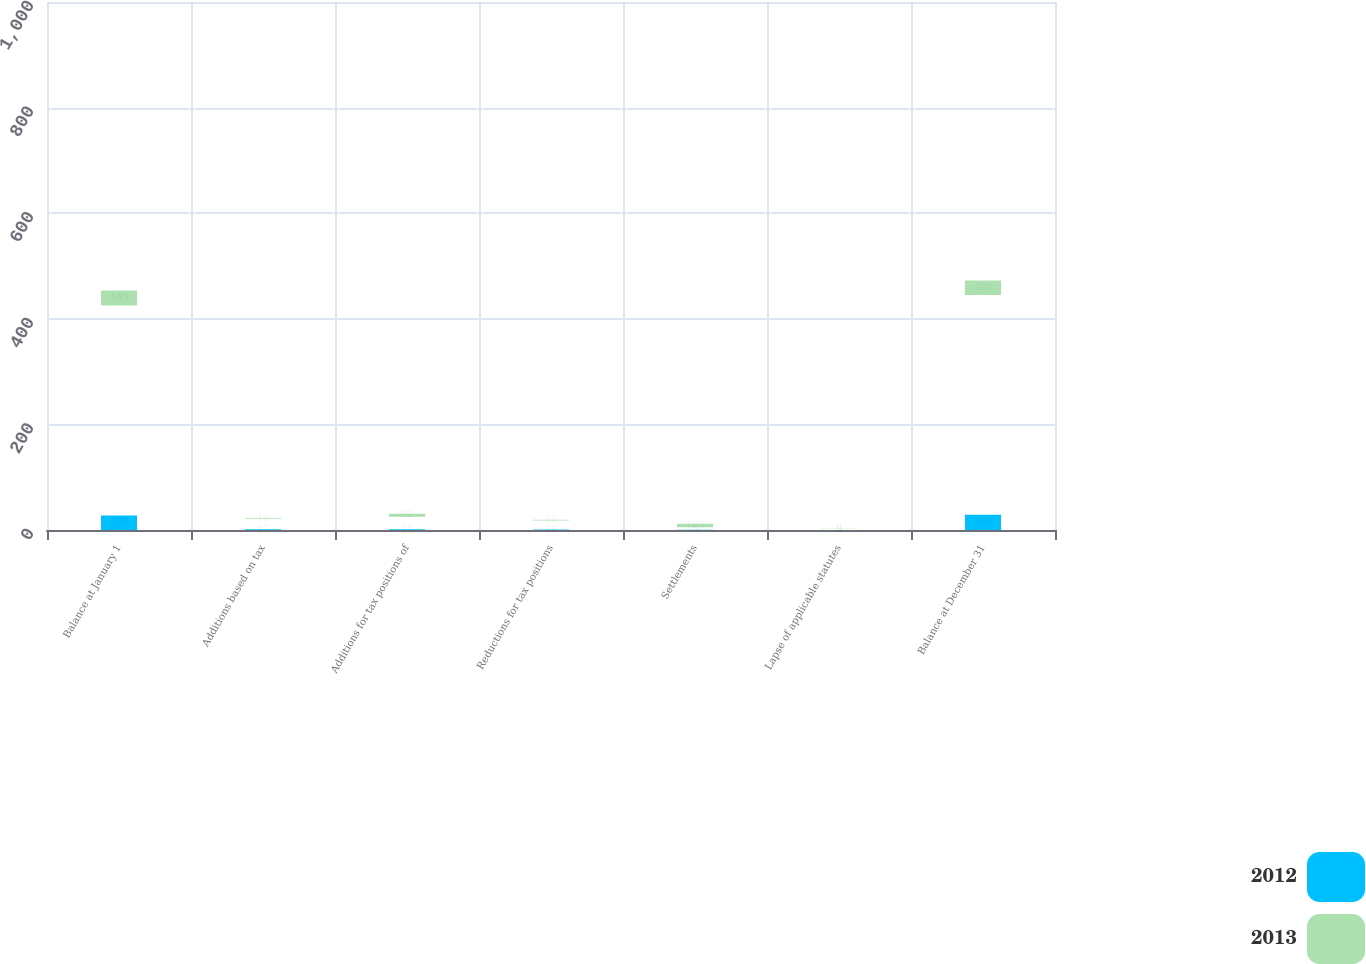Convert chart to OTSL. <chart><loc_0><loc_0><loc_500><loc_500><stacked_bar_chart><ecel><fcel>Balance at January 1<fcel>Additions based on tax<fcel>Additions for tax positions of<fcel>Reductions for tax positions<fcel>Settlements<fcel>Lapse of applicable statutes<fcel>Balance at December 31<nl><fcel>2012<fcel>425<fcel>21<fcel>25<fcel>18<fcel>5<fcel>3<fcel>445<nl><fcel>2013<fcel>445<fcel>16<fcel>92<fcel>19<fcel>103<fcel>6<fcel>425<nl></chart> 